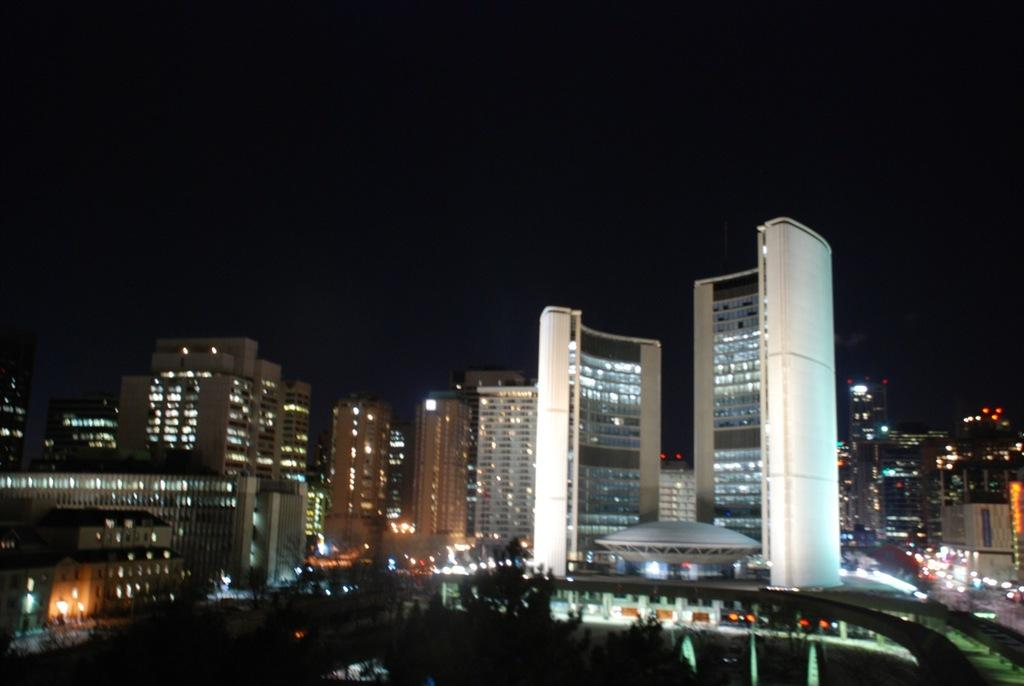What type of structures can be seen in the image? There are buildings in the image. What can be seen illuminating the scene in the image? There are lights visible in the image. What type of vegetation is present in the image? There are trees in the image. What is visible in the background of the image? The sky is visible in the background of the image. What reason does the son have for not attending the event in the image? There is no event or son present in the image; it features buildings, lights, trees, and the sky. What thrilling activity is the person in the image participating in? There is no person participating in any activity visible in the image. 